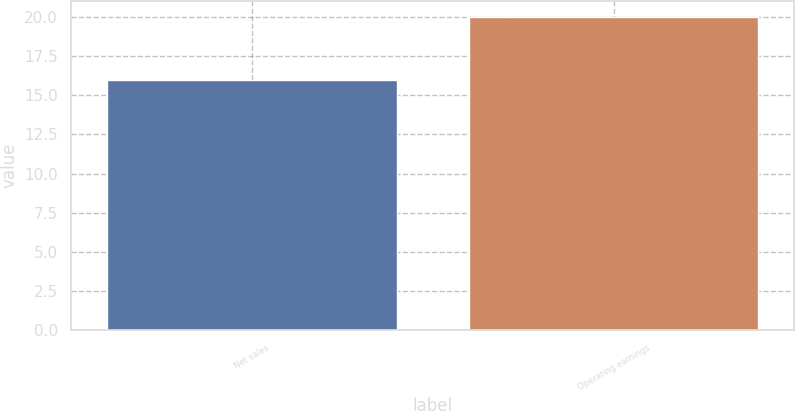<chart> <loc_0><loc_0><loc_500><loc_500><bar_chart><fcel>Net sales<fcel>Operating earnings<nl><fcel>16<fcel>20<nl></chart> 